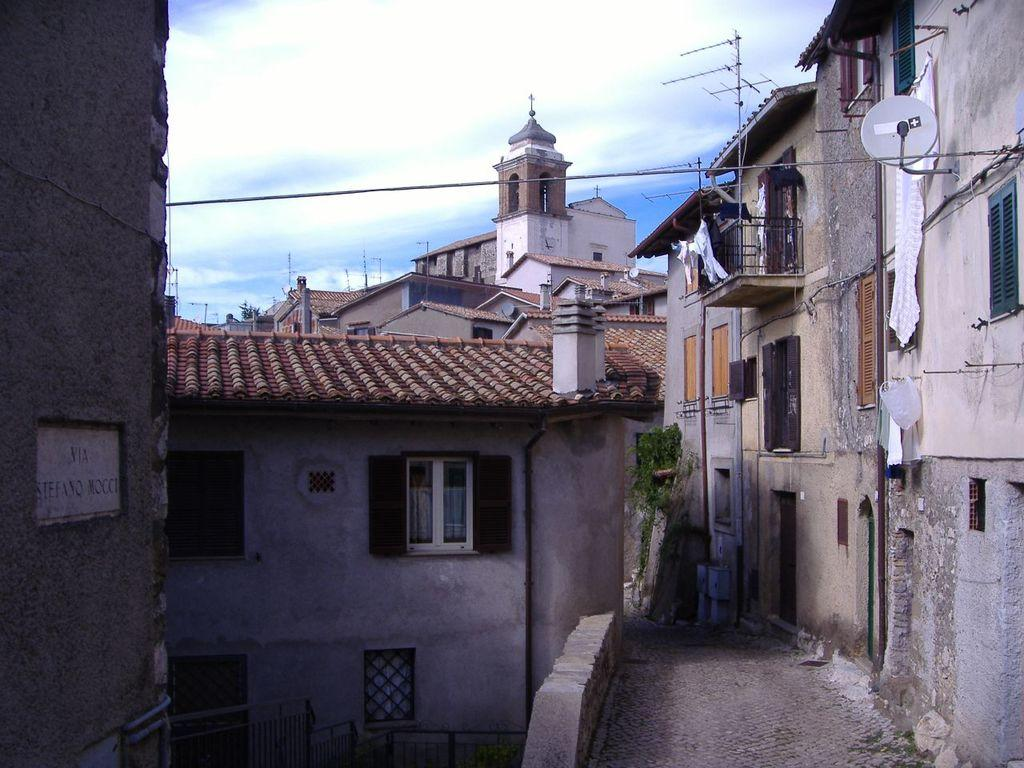What type of structures are visible in the image? There are buildings with windows in the image. What features do the buildings have? The buildings have doors and objects attached to them. What other elements can be seen in the image? There are poles, fencing, and a name plate in the image. What is visible in the background of the image? The sky is visible in the image, and clouds are present in the sky. What type of sock is hanging from the name plate in the image? There is no sock present in the image; it only features buildings, poles, fencing, and a name plate. 